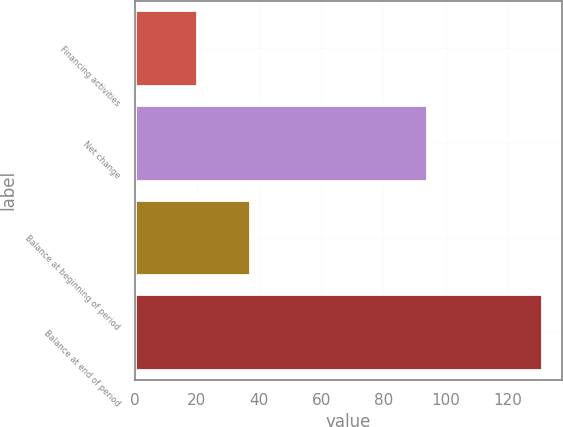<chart> <loc_0><loc_0><loc_500><loc_500><bar_chart><fcel>Financing activities<fcel>Net change<fcel>Balance at beginning of period<fcel>Balance at end of period<nl><fcel>20<fcel>94<fcel>37<fcel>131<nl></chart> 